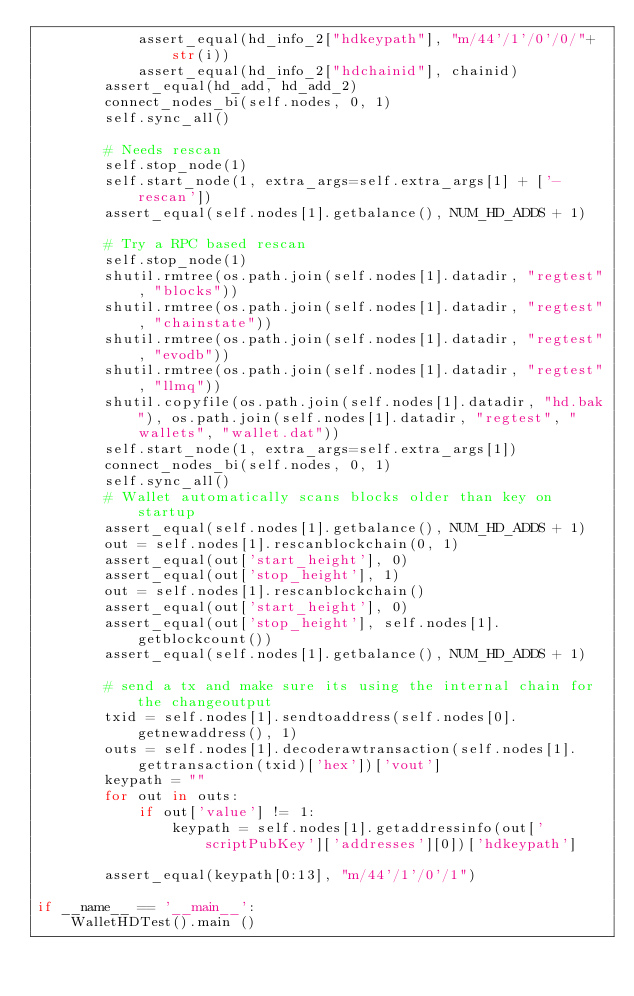Convert code to text. <code><loc_0><loc_0><loc_500><loc_500><_Python_>            assert_equal(hd_info_2["hdkeypath"], "m/44'/1'/0'/0/"+str(i))
            assert_equal(hd_info_2["hdchainid"], chainid)
        assert_equal(hd_add, hd_add_2)
        connect_nodes_bi(self.nodes, 0, 1)
        self.sync_all()

        # Needs rescan
        self.stop_node(1)
        self.start_node(1, extra_args=self.extra_args[1] + ['-rescan'])
        assert_equal(self.nodes[1].getbalance(), NUM_HD_ADDS + 1)

        # Try a RPC based rescan
        self.stop_node(1)
        shutil.rmtree(os.path.join(self.nodes[1].datadir, "regtest", "blocks"))
        shutil.rmtree(os.path.join(self.nodes[1].datadir, "regtest", "chainstate"))
        shutil.rmtree(os.path.join(self.nodes[1].datadir, "regtest", "evodb"))
        shutil.rmtree(os.path.join(self.nodes[1].datadir, "regtest", "llmq"))
        shutil.copyfile(os.path.join(self.nodes[1].datadir, "hd.bak"), os.path.join(self.nodes[1].datadir, "regtest", "wallets", "wallet.dat"))
        self.start_node(1, extra_args=self.extra_args[1])
        connect_nodes_bi(self.nodes, 0, 1)
        self.sync_all()
        # Wallet automatically scans blocks older than key on startup
        assert_equal(self.nodes[1].getbalance(), NUM_HD_ADDS + 1)
        out = self.nodes[1].rescanblockchain(0, 1)
        assert_equal(out['start_height'], 0)
        assert_equal(out['stop_height'], 1)
        out = self.nodes[1].rescanblockchain()
        assert_equal(out['start_height'], 0)
        assert_equal(out['stop_height'], self.nodes[1].getblockcount())
        assert_equal(self.nodes[1].getbalance(), NUM_HD_ADDS + 1)

        # send a tx and make sure its using the internal chain for the changeoutput
        txid = self.nodes[1].sendtoaddress(self.nodes[0].getnewaddress(), 1)
        outs = self.nodes[1].decoderawtransaction(self.nodes[1].gettransaction(txid)['hex'])['vout']
        keypath = ""
        for out in outs:
            if out['value'] != 1:
                keypath = self.nodes[1].getaddressinfo(out['scriptPubKey']['addresses'][0])['hdkeypath']

        assert_equal(keypath[0:13], "m/44'/1'/0'/1")

if __name__ == '__main__':
    WalletHDTest().main ()
</code> 